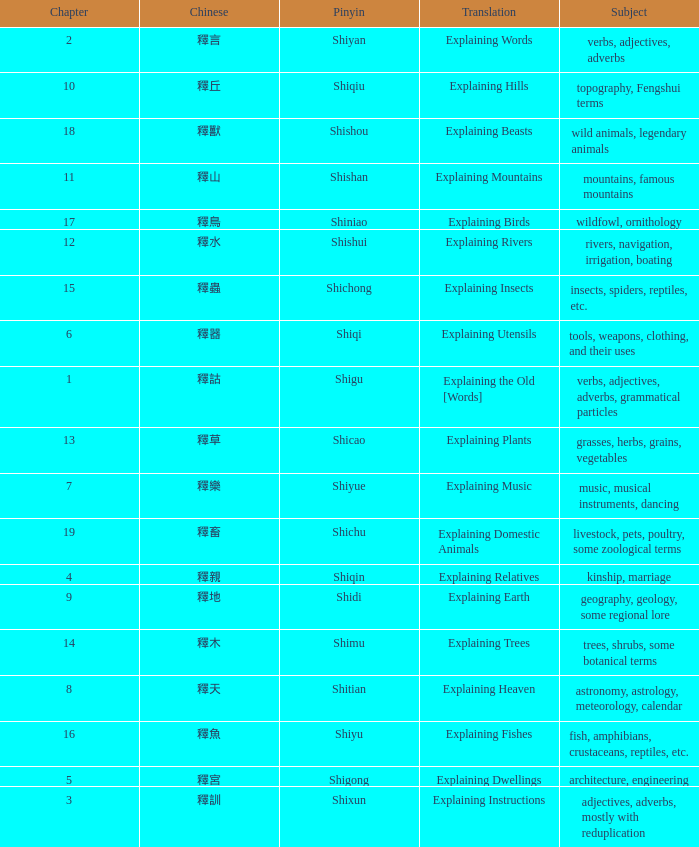Name the total number of chapter for chinese of 釋宮 1.0. 